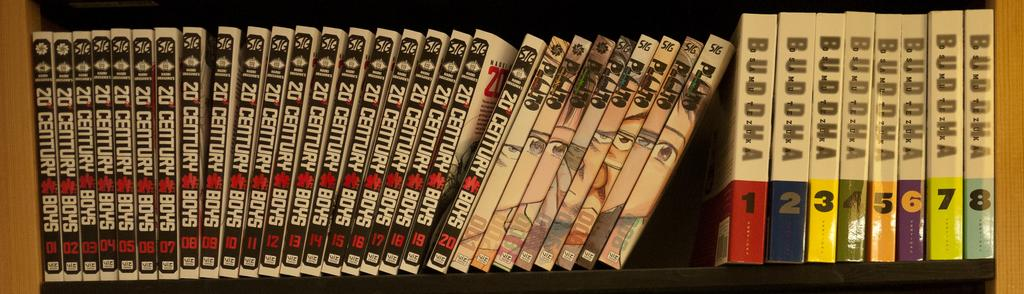<image>
Summarize the visual content of the image. Twenty volumes of 20th Century Boys are stacked on a shelf. 